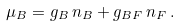Convert formula to latex. <formula><loc_0><loc_0><loc_500><loc_500>\mu _ { B } = g _ { B } \, n _ { B } + g _ { B F } \, n _ { F } \, .</formula> 